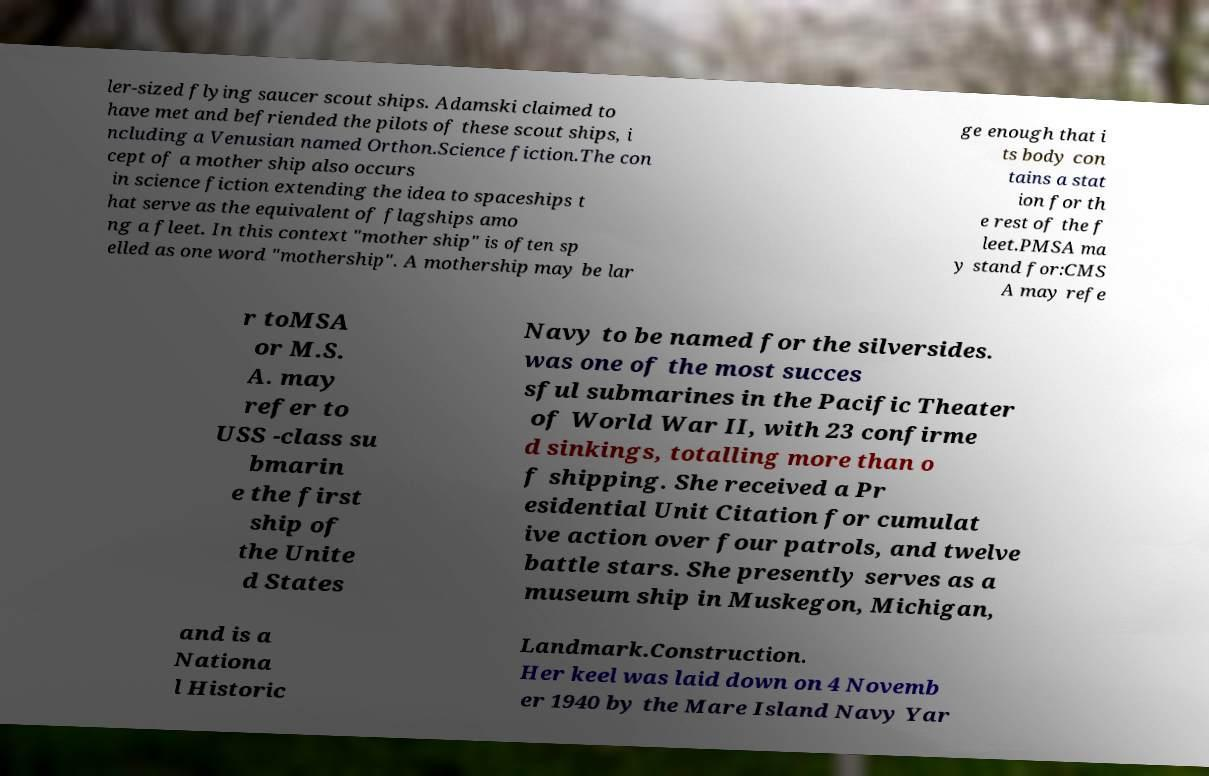For documentation purposes, I need the text within this image transcribed. Could you provide that? ler-sized flying saucer scout ships. Adamski claimed to have met and befriended the pilots of these scout ships, i ncluding a Venusian named Orthon.Science fiction.The con cept of a mother ship also occurs in science fiction extending the idea to spaceships t hat serve as the equivalent of flagships amo ng a fleet. In this context "mother ship" is often sp elled as one word "mothership". A mothership may be lar ge enough that i ts body con tains a stat ion for th e rest of the f leet.PMSA ma y stand for:CMS A may refe r toMSA or M.S. A. may refer to USS -class su bmarin e the first ship of the Unite d States Navy to be named for the silversides. was one of the most succes sful submarines in the Pacific Theater of World War II, with 23 confirme d sinkings, totalling more than o f shipping. She received a Pr esidential Unit Citation for cumulat ive action over four patrols, and twelve battle stars. She presently serves as a museum ship in Muskegon, Michigan, and is a Nationa l Historic Landmark.Construction. Her keel was laid down on 4 Novemb er 1940 by the Mare Island Navy Yar 